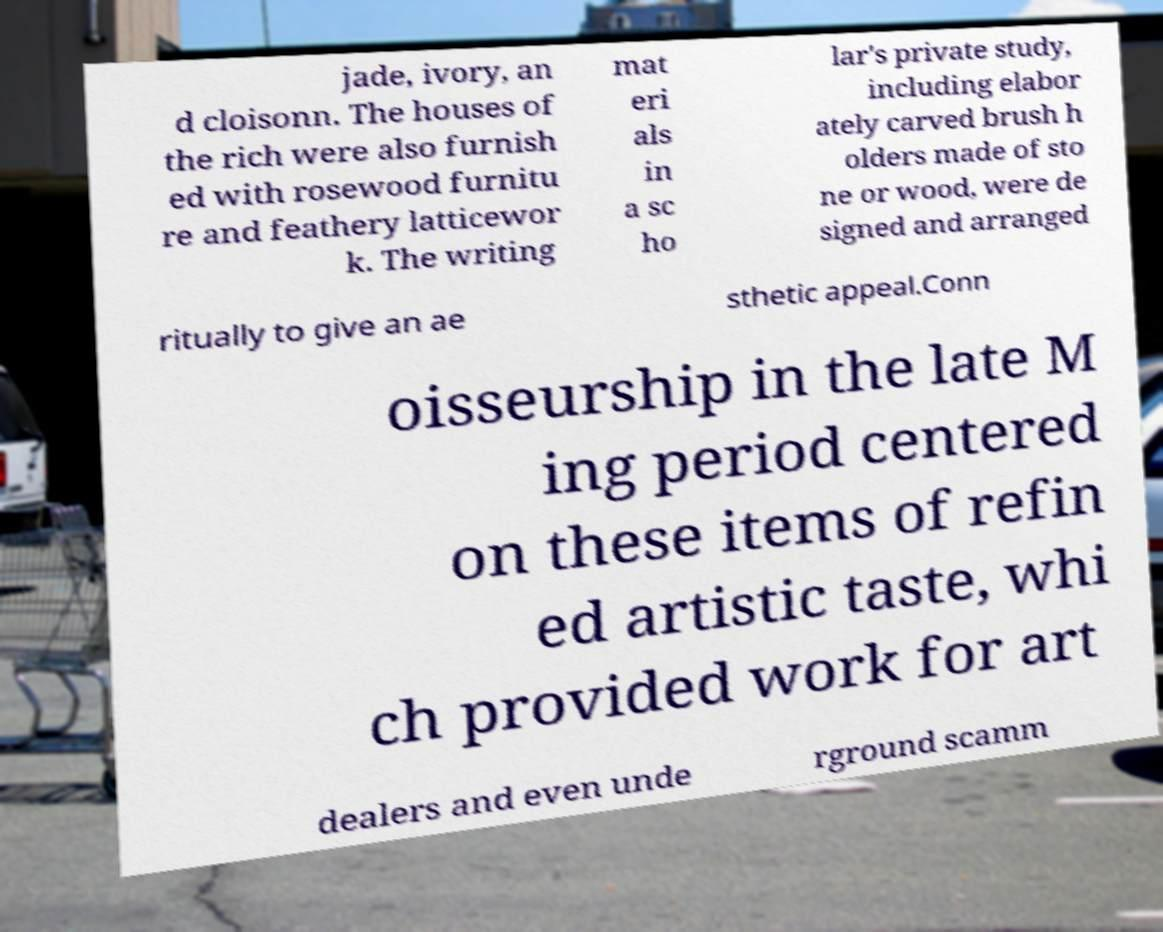Can you accurately transcribe the text from the provided image for me? jade, ivory, an d cloisonn. The houses of the rich were also furnish ed with rosewood furnitu re and feathery latticewor k. The writing mat eri als in a sc ho lar's private study, including elabor ately carved brush h olders made of sto ne or wood, were de signed and arranged ritually to give an ae sthetic appeal.Conn oisseurship in the late M ing period centered on these items of refin ed artistic taste, whi ch provided work for art dealers and even unde rground scamm 